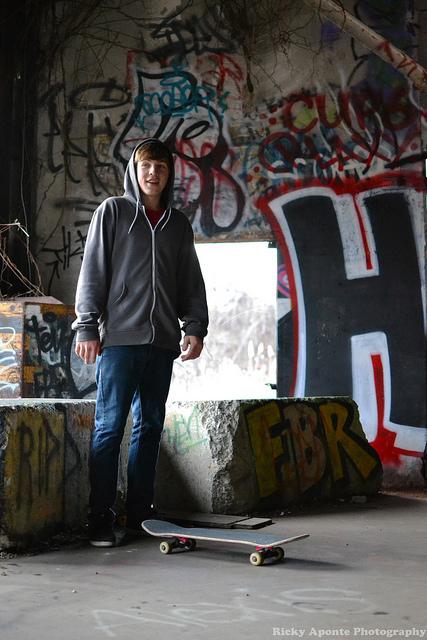Is there someone riding the skateboard?
Give a very brief answer. No. Is this person sad?
Write a very short answer. No. What is on the wall?
Keep it brief. Graffiti. Is the skater doing a trick?
Keep it brief. No. What is sitting on the ground near his feet?
Answer briefly. Skateboard. Is he wearing a hoodie?
Write a very short answer. Yes. How many skateboards are in the picture?
Be succinct. 1. What is on the walls and bench?
Keep it brief. Graffiti. Are the man's arms hanging down by his sides?
Quick response, please. Yes. Has the picture been taken recently?
Give a very brief answer. Yes. What big letter is in red?
Short answer required. H. 